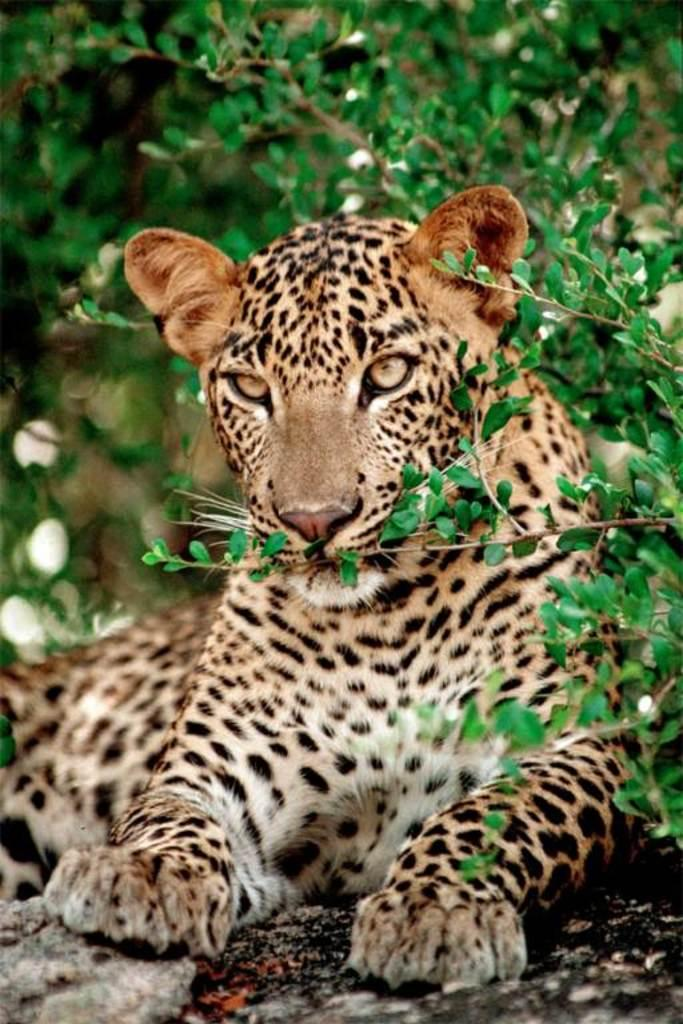What animal is the main subject of the image? There is a cheetah in the image. What is the cheetah doing in the image? The cheetah is lying on the ground. What can be seen in the background of the image? There are trees in the background of the image. What type of stitch is the doctor using to treat the cheetah's injury in the image? There is no doctor or injury present in the image; it features a cheetah lying on the ground with trees in the background. How much money is the cheetah holding in the image? There is no money present in the image; it features a cheetah lying on the ground with trees in the background. 